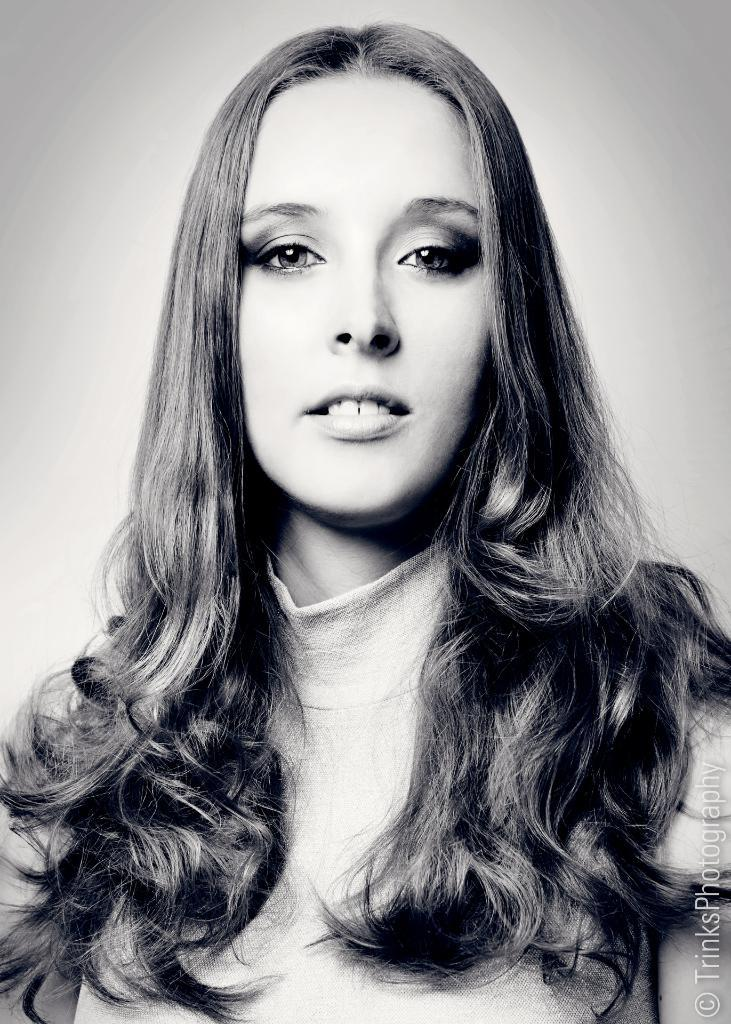Who is present in the image? There is a woman in the image. What is the woman doing in the image? The woman is smiling in the image. Is there any text visible in the image? Yes, there is some text in the bottom right corner of the image. What type of animal is flying a kite in the image? There is no animal or kite present in the image. What punishment is the woman receiving in the image? There is no indication of punishment in the image; the woman is simply smiling. 